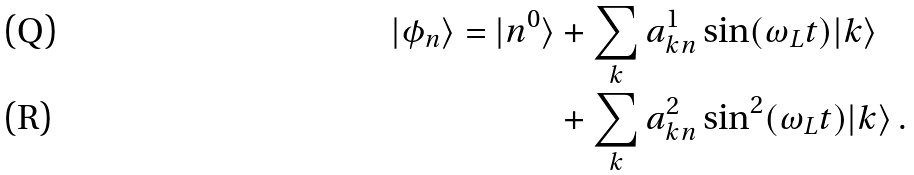Convert formula to latex. <formula><loc_0><loc_0><loc_500><loc_500>| \phi _ { n } \rangle = | n ^ { 0 } \rangle & + \sum _ { k } a ^ { 1 } _ { k n } \sin ( \omega _ { L } t ) | k \rangle \\ & + \sum _ { k } a ^ { 2 } _ { k n } \sin ^ { 2 } ( \omega _ { L } t ) | k \rangle \, .</formula> 